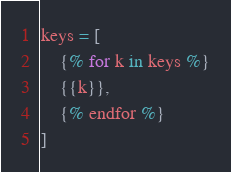<code> <loc_0><loc_0><loc_500><loc_500><_Python_>keys = [
    {% for k in keys %}
    {{k}},
    {% endfor %}
]</code> 